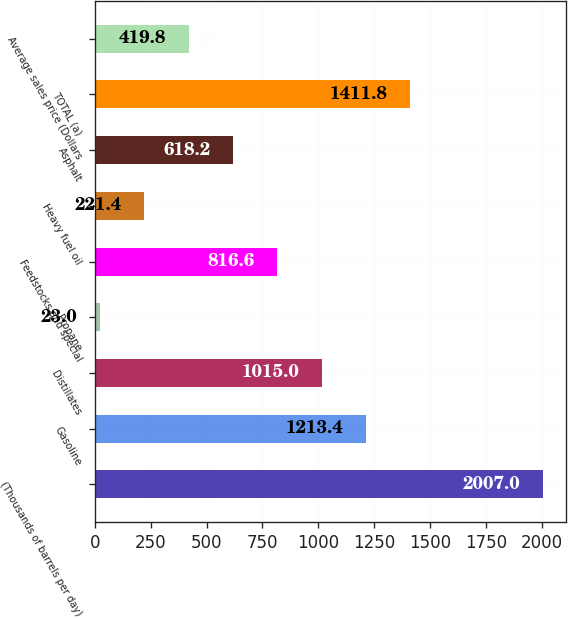Convert chart. <chart><loc_0><loc_0><loc_500><loc_500><bar_chart><fcel>(Thousands of barrels per day)<fcel>Gasoline<fcel>Distillates<fcel>Propane<fcel>Feedstocks and special<fcel>Heavy fuel oil<fcel>Asphalt<fcel>TOTAL (a)<fcel>Average sales price (Dollars<nl><fcel>2007<fcel>1213.4<fcel>1015<fcel>23<fcel>816.6<fcel>221.4<fcel>618.2<fcel>1411.8<fcel>419.8<nl></chart> 